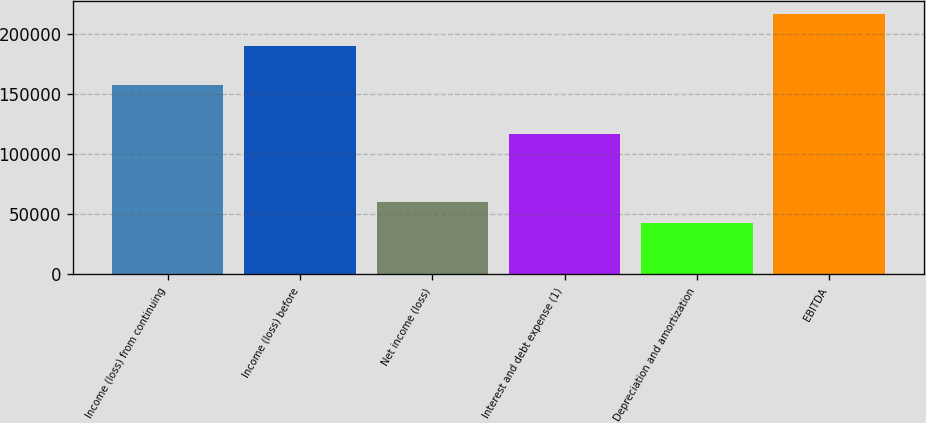Convert chart. <chart><loc_0><loc_0><loc_500><loc_500><bar_chart><fcel>Income (loss) from continuing<fcel>Income (loss) before<fcel>Net income (loss)<fcel>Interest and debt expense (1)<fcel>Depreciation and amortization<fcel>EBITDA<nl><fcel>157564<fcel>190167<fcel>60544.3<fcel>116662<fcel>43179<fcel>216832<nl></chart> 